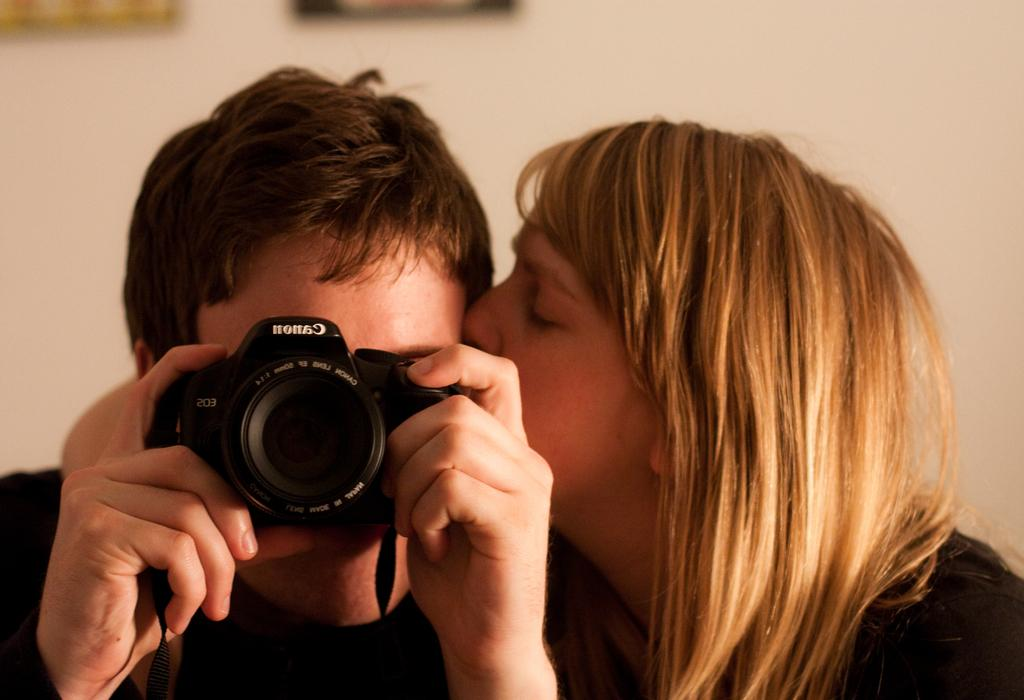Where is the lady located in the image? The lady is in the right corner of the image. What is the lady doing in the image? The lady is kissing another person in the image. What is the person beside the lady holding? The person beside the lady is holding a camera in his hands. What type of zipper can be seen on the lady's clothing in the image? There is no zipper visible on the lady's clothing in the image. How many thumbs does the person holding the camera have in the image? The number of thumbs the person holding the camera has cannot be determined from the image. 